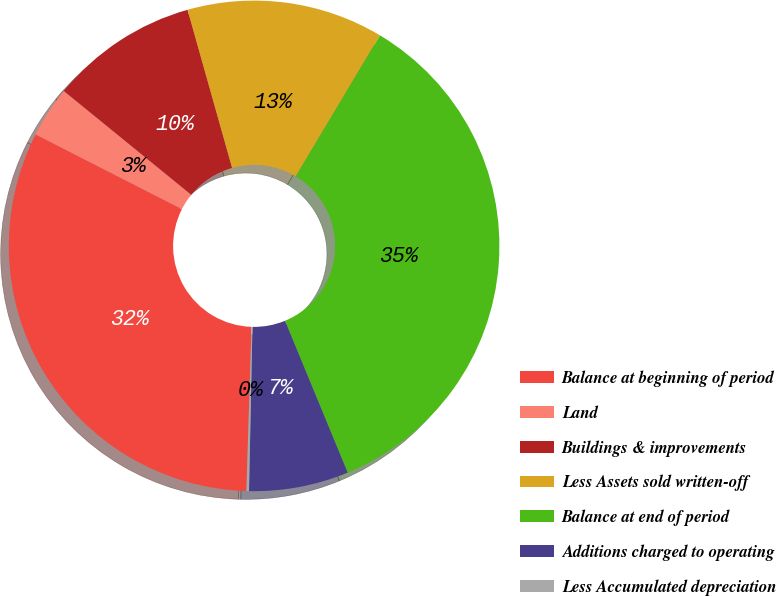<chart> <loc_0><loc_0><loc_500><loc_500><pie_chart><fcel>Balance at beginning of period<fcel>Land<fcel>Buildings & improvements<fcel>Less Assets sold written-off<fcel>Balance at end of period<fcel>Additions charged to operating<fcel>Less Accumulated depreciation<nl><fcel>32.01%<fcel>3.37%<fcel>9.75%<fcel>12.95%<fcel>35.2%<fcel>6.56%<fcel>0.17%<nl></chart> 